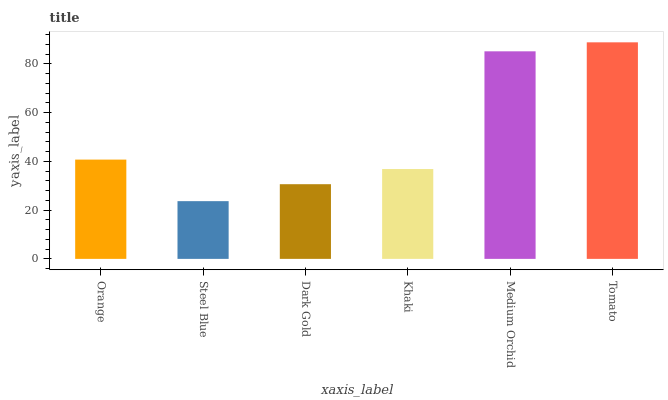Is Steel Blue the minimum?
Answer yes or no. Yes. Is Tomato the maximum?
Answer yes or no. Yes. Is Dark Gold the minimum?
Answer yes or no. No. Is Dark Gold the maximum?
Answer yes or no. No. Is Dark Gold greater than Steel Blue?
Answer yes or no. Yes. Is Steel Blue less than Dark Gold?
Answer yes or no. Yes. Is Steel Blue greater than Dark Gold?
Answer yes or no. No. Is Dark Gold less than Steel Blue?
Answer yes or no. No. Is Orange the high median?
Answer yes or no. Yes. Is Khaki the low median?
Answer yes or no. Yes. Is Steel Blue the high median?
Answer yes or no. No. Is Tomato the low median?
Answer yes or no. No. 